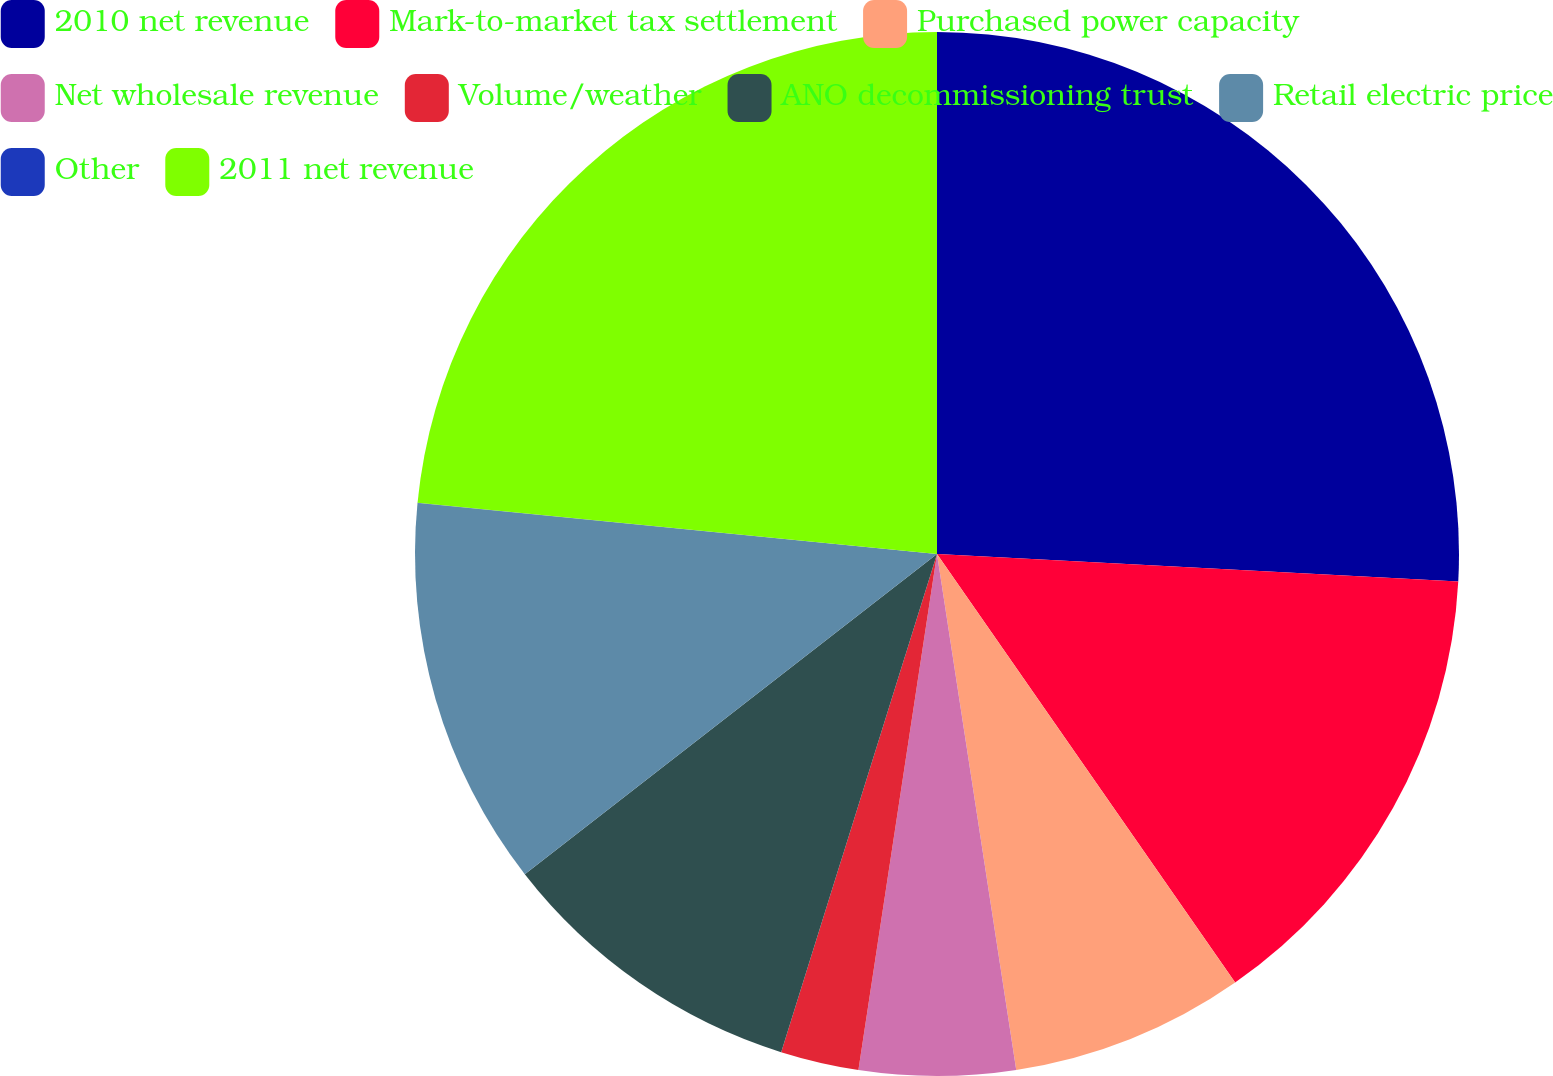Convert chart to OTSL. <chart><loc_0><loc_0><loc_500><loc_500><pie_chart><fcel>2010 net revenue<fcel>Mark-to-market tax settlement<fcel>Purchased power capacity<fcel>Net wholesale revenue<fcel>Volume/weather<fcel>ANO decommissioning trust<fcel>Retail electric price<fcel>Other<fcel>2011 net revenue<nl><fcel>25.84%<fcel>14.48%<fcel>7.25%<fcel>4.83%<fcel>2.42%<fcel>9.66%<fcel>12.07%<fcel>0.01%<fcel>23.43%<nl></chart> 